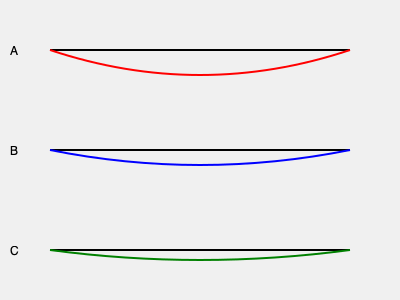The diagram shows cross-sectional wear patterns of brake pads from three different trucks in your fleet. Which wear pattern indicates the most urgent need for brake pad replacement, and what could be the potential cause? To analyze the brake pad wear patterns:

1. Pattern A (top): Shows significant uneven wear with more material loss in the center. This indicates:
   - Possible overheating issues
   - Uneven pressure distribution
   - Highest risk of brake failure

2. Pattern B (middle): Displays moderate, relatively even wear across the pad. This suggests:
   - Normal wear pattern
   - Proper brake system function

3. Pattern C (bottom): Shows minimal wear, indicating:
   - New or recently replaced brake pads
   - Least urgent need for replacement

Comparing the patterns:
- Pattern A is the most concerning due to its uneven wear and significant material loss.
- The center wear in Pattern A could be caused by:
  a) Brake caliper issues (sticking or misalignment)
  b) Rotor problems (warping or thickness variation)
  c) Improper pad installation

Given the severity of Pattern A's wear, it poses the highest risk of brake failure and requires immediate attention. Trucks showing this wear pattern should be prioritized for brake system inspection and pad replacement to ensure fleet safety and compliance with maintenance regulations.
Answer: Pattern A; likely caused by caliper issues, rotor problems, or improper installation. 